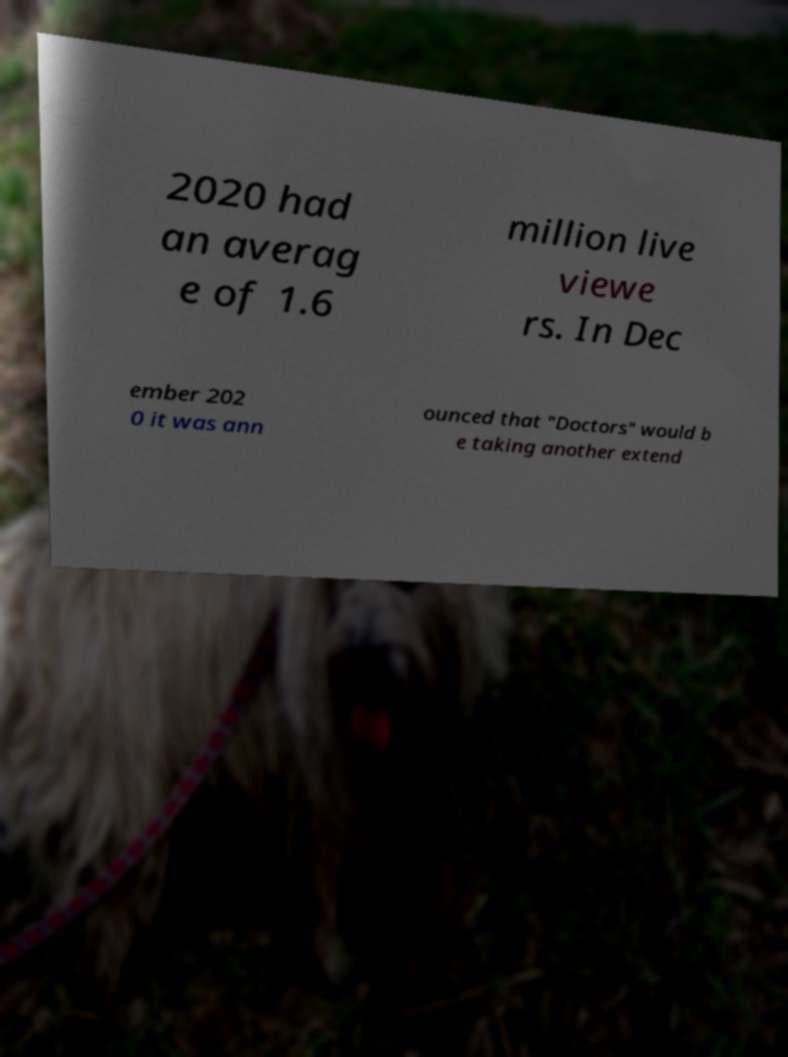For documentation purposes, I need the text within this image transcribed. Could you provide that? 2020 had an averag e of 1.6 million live viewe rs. In Dec ember 202 0 it was ann ounced that "Doctors" would b e taking another extend 